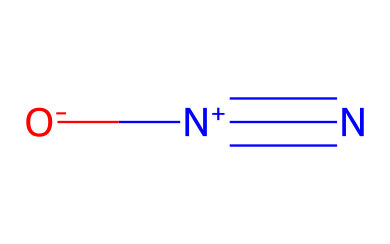What is the molecular formula of this gas? The molecular formula can be derived from the SMILES representation. In it, there are two nitrogen atoms and one oxygen atom, leading to the formula N2O.
Answer: N2O How many total atoms are in this molecule? By counting the atoms present in the molecular formula, we identify two nitrogen atoms and one oxygen atom, which sums to three total atoms in the molecule.
Answer: 3 What type of bonding is present in nitrous oxide? Nitrous oxide exhibits covalent bonding, as represented by the shared electrons among nitrogen and oxygen, which are non-metals.
Answer: covalent What is the charge of the nitrogen atom in the structure? The SMILES denotes that one nitrogen atom is positively charged, as indicated by the "[N+]" notation, while the other is neutral.
Answer: positive What are the implications of the molecular arrangement for its usage in injury treatments? The molecular arrangement indicates that nitrous oxide has anesthetic properties due to its stable structure and low reactivity, making it effective for pain relief during medical procedures.
Answer: anesthetic properties How many bonds are formed between the nitrogen and oxygen in this molecule? The bonding arrangement in the structure reveals a triple bond between the two nitrogen atoms (indicated by N#N) and a single bond to the oxygen atom, leading to a total of four bonds.
Answer: 4 What is the role of nitrous oxide in sports medicine? In sports medicine, nitrous oxide is utilized primarily for pain relief and sedation, taking advantage of its anesthetic properties to manage injury treatments effectively.
Answer: pain relief 